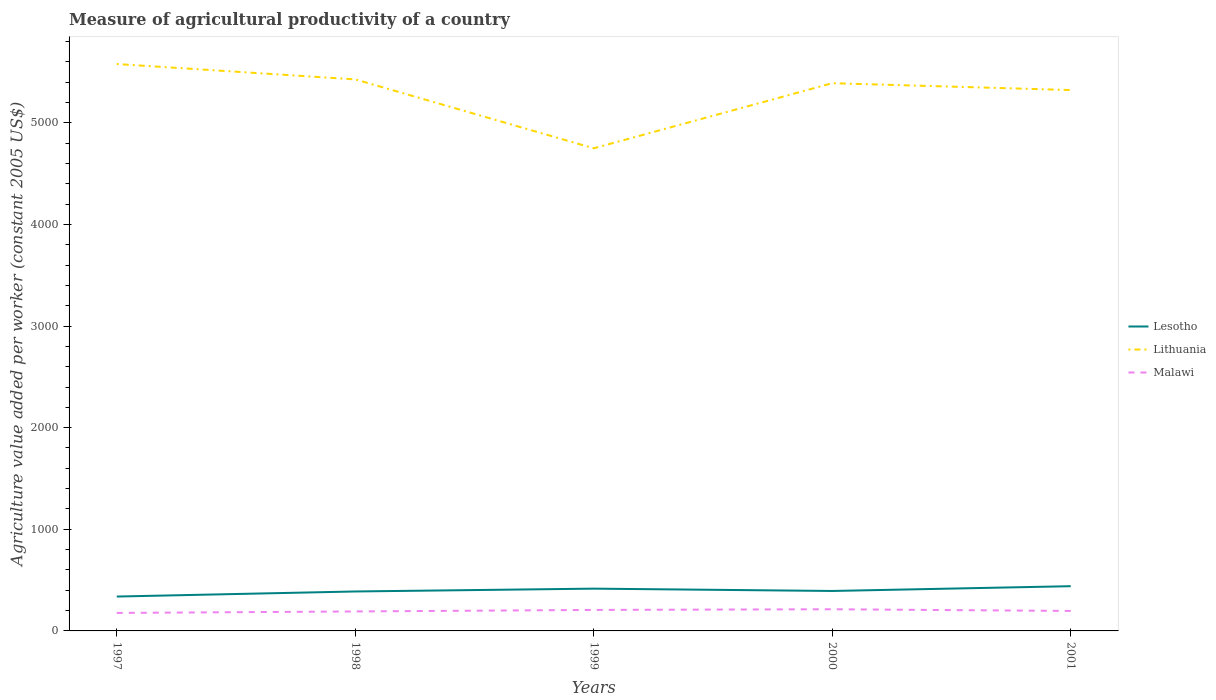Does the line corresponding to Lithuania intersect with the line corresponding to Lesotho?
Provide a succinct answer. No. Is the number of lines equal to the number of legend labels?
Make the answer very short. Yes. Across all years, what is the maximum measure of agricultural productivity in Malawi?
Offer a terse response. 177.04. In which year was the measure of agricultural productivity in Lithuania maximum?
Provide a short and direct response. 1999. What is the total measure of agricultural productivity in Lithuania in the graph?
Give a very brief answer. 256.21. What is the difference between the highest and the second highest measure of agricultural productivity in Lithuania?
Your response must be concise. 829.35. How many lines are there?
Provide a short and direct response. 3. How many years are there in the graph?
Keep it short and to the point. 5. What is the difference between two consecutive major ticks on the Y-axis?
Make the answer very short. 1000. Does the graph contain any zero values?
Your answer should be compact. No. Where does the legend appear in the graph?
Give a very brief answer. Center right. How are the legend labels stacked?
Give a very brief answer. Vertical. What is the title of the graph?
Offer a very short reply. Measure of agricultural productivity of a country. What is the label or title of the X-axis?
Make the answer very short. Years. What is the label or title of the Y-axis?
Offer a terse response. Agriculture value added per worker (constant 2005 US$). What is the Agriculture value added per worker (constant 2005 US$) of Lesotho in 1997?
Offer a terse response. 338.18. What is the Agriculture value added per worker (constant 2005 US$) in Lithuania in 1997?
Make the answer very short. 5578.12. What is the Agriculture value added per worker (constant 2005 US$) in Malawi in 1997?
Ensure brevity in your answer.  177.04. What is the Agriculture value added per worker (constant 2005 US$) of Lesotho in 1998?
Ensure brevity in your answer.  388.21. What is the Agriculture value added per worker (constant 2005 US$) of Lithuania in 1998?
Offer a terse response. 5426.79. What is the Agriculture value added per worker (constant 2005 US$) in Malawi in 1998?
Make the answer very short. 191.59. What is the Agriculture value added per worker (constant 2005 US$) in Lesotho in 1999?
Your answer should be compact. 416.03. What is the Agriculture value added per worker (constant 2005 US$) in Lithuania in 1999?
Keep it short and to the point. 4748.77. What is the Agriculture value added per worker (constant 2005 US$) in Malawi in 1999?
Your response must be concise. 206.56. What is the Agriculture value added per worker (constant 2005 US$) of Lesotho in 2000?
Provide a succinct answer. 393.16. What is the Agriculture value added per worker (constant 2005 US$) in Lithuania in 2000?
Offer a terse response. 5389.48. What is the Agriculture value added per worker (constant 2005 US$) of Malawi in 2000?
Give a very brief answer. 213.16. What is the Agriculture value added per worker (constant 2005 US$) in Lesotho in 2001?
Your answer should be very brief. 440.23. What is the Agriculture value added per worker (constant 2005 US$) of Lithuania in 2001?
Offer a terse response. 5321.91. What is the Agriculture value added per worker (constant 2005 US$) in Malawi in 2001?
Your answer should be compact. 196.64. Across all years, what is the maximum Agriculture value added per worker (constant 2005 US$) of Lesotho?
Your response must be concise. 440.23. Across all years, what is the maximum Agriculture value added per worker (constant 2005 US$) of Lithuania?
Your answer should be very brief. 5578.12. Across all years, what is the maximum Agriculture value added per worker (constant 2005 US$) in Malawi?
Offer a terse response. 213.16. Across all years, what is the minimum Agriculture value added per worker (constant 2005 US$) of Lesotho?
Keep it short and to the point. 338.18. Across all years, what is the minimum Agriculture value added per worker (constant 2005 US$) in Lithuania?
Your answer should be very brief. 4748.77. Across all years, what is the minimum Agriculture value added per worker (constant 2005 US$) in Malawi?
Make the answer very short. 177.04. What is the total Agriculture value added per worker (constant 2005 US$) in Lesotho in the graph?
Your answer should be very brief. 1975.81. What is the total Agriculture value added per worker (constant 2005 US$) in Lithuania in the graph?
Your answer should be compact. 2.65e+04. What is the total Agriculture value added per worker (constant 2005 US$) of Malawi in the graph?
Ensure brevity in your answer.  984.99. What is the difference between the Agriculture value added per worker (constant 2005 US$) in Lesotho in 1997 and that in 1998?
Offer a very short reply. -50.03. What is the difference between the Agriculture value added per worker (constant 2005 US$) in Lithuania in 1997 and that in 1998?
Keep it short and to the point. 151.33. What is the difference between the Agriculture value added per worker (constant 2005 US$) in Malawi in 1997 and that in 1998?
Your answer should be compact. -14.55. What is the difference between the Agriculture value added per worker (constant 2005 US$) in Lesotho in 1997 and that in 1999?
Your response must be concise. -77.84. What is the difference between the Agriculture value added per worker (constant 2005 US$) in Lithuania in 1997 and that in 1999?
Provide a short and direct response. 829.35. What is the difference between the Agriculture value added per worker (constant 2005 US$) of Malawi in 1997 and that in 1999?
Keep it short and to the point. -29.52. What is the difference between the Agriculture value added per worker (constant 2005 US$) in Lesotho in 1997 and that in 2000?
Provide a succinct answer. -54.98. What is the difference between the Agriculture value added per worker (constant 2005 US$) in Lithuania in 1997 and that in 2000?
Give a very brief answer. 188.64. What is the difference between the Agriculture value added per worker (constant 2005 US$) of Malawi in 1997 and that in 2000?
Offer a very short reply. -36.13. What is the difference between the Agriculture value added per worker (constant 2005 US$) in Lesotho in 1997 and that in 2001?
Your answer should be compact. -102.05. What is the difference between the Agriculture value added per worker (constant 2005 US$) in Lithuania in 1997 and that in 2001?
Make the answer very short. 256.21. What is the difference between the Agriculture value added per worker (constant 2005 US$) of Malawi in 1997 and that in 2001?
Your answer should be very brief. -19.6. What is the difference between the Agriculture value added per worker (constant 2005 US$) of Lesotho in 1998 and that in 1999?
Your answer should be compact. -27.81. What is the difference between the Agriculture value added per worker (constant 2005 US$) in Lithuania in 1998 and that in 1999?
Your answer should be compact. 678.02. What is the difference between the Agriculture value added per worker (constant 2005 US$) of Malawi in 1998 and that in 1999?
Give a very brief answer. -14.97. What is the difference between the Agriculture value added per worker (constant 2005 US$) in Lesotho in 1998 and that in 2000?
Provide a succinct answer. -4.95. What is the difference between the Agriculture value added per worker (constant 2005 US$) in Lithuania in 1998 and that in 2000?
Give a very brief answer. 37.32. What is the difference between the Agriculture value added per worker (constant 2005 US$) in Malawi in 1998 and that in 2000?
Give a very brief answer. -21.57. What is the difference between the Agriculture value added per worker (constant 2005 US$) in Lesotho in 1998 and that in 2001?
Make the answer very short. -52.02. What is the difference between the Agriculture value added per worker (constant 2005 US$) in Lithuania in 1998 and that in 2001?
Your answer should be very brief. 104.88. What is the difference between the Agriculture value added per worker (constant 2005 US$) of Malawi in 1998 and that in 2001?
Offer a very short reply. -5.05. What is the difference between the Agriculture value added per worker (constant 2005 US$) in Lesotho in 1999 and that in 2000?
Make the answer very short. 22.86. What is the difference between the Agriculture value added per worker (constant 2005 US$) in Lithuania in 1999 and that in 2000?
Offer a terse response. -640.71. What is the difference between the Agriculture value added per worker (constant 2005 US$) of Malawi in 1999 and that in 2000?
Provide a short and direct response. -6.6. What is the difference between the Agriculture value added per worker (constant 2005 US$) of Lesotho in 1999 and that in 2001?
Make the answer very short. -24.2. What is the difference between the Agriculture value added per worker (constant 2005 US$) in Lithuania in 1999 and that in 2001?
Offer a terse response. -573.14. What is the difference between the Agriculture value added per worker (constant 2005 US$) of Malawi in 1999 and that in 2001?
Provide a short and direct response. 9.92. What is the difference between the Agriculture value added per worker (constant 2005 US$) of Lesotho in 2000 and that in 2001?
Provide a short and direct response. -47.07. What is the difference between the Agriculture value added per worker (constant 2005 US$) in Lithuania in 2000 and that in 2001?
Your answer should be very brief. 67.57. What is the difference between the Agriculture value added per worker (constant 2005 US$) in Malawi in 2000 and that in 2001?
Your answer should be compact. 16.53. What is the difference between the Agriculture value added per worker (constant 2005 US$) in Lesotho in 1997 and the Agriculture value added per worker (constant 2005 US$) in Lithuania in 1998?
Your response must be concise. -5088.61. What is the difference between the Agriculture value added per worker (constant 2005 US$) in Lesotho in 1997 and the Agriculture value added per worker (constant 2005 US$) in Malawi in 1998?
Offer a terse response. 146.59. What is the difference between the Agriculture value added per worker (constant 2005 US$) in Lithuania in 1997 and the Agriculture value added per worker (constant 2005 US$) in Malawi in 1998?
Your answer should be compact. 5386.53. What is the difference between the Agriculture value added per worker (constant 2005 US$) in Lesotho in 1997 and the Agriculture value added per worker (constant 2005 US$) in Lithuania in 1999?
Make the answer very short. -4410.59. What is the difference between the Agriculture value added per worker (constant 2005 US$) of Lesotho in 1997 and the Agriculture value added per worker (constant 2005 US$) of Malawi in 1999?
Offer a terse response. 131.62. What is the difference between the Agriculture value added per worker (constant 2005 US$) in Lithuania in 1997 and the Agriculture value added per worker (constant 2005 US$) in Malawi in 1999?
Your response must be concise. 5371.56. What is the difference between the Agriculture value added per worker (constant 2005 US$) in Lesotho in 1997 and the Agriculture value added per worker (constant 2005 US$) in Lithuania in 2000?
Give a very brief answer. -5051.29. What is the difference between the Agriculture value added per worker (constant 2005 US$) of Lesotho in 1997 and the Agriculture value added per worker (constant 2005 US$) of Malawi in 2000?
Make the answer very short. 125.02. What is the difference between the Agriculture value added per worker (constant 2005 US$) in Lithuania in 1997 and the Agriculture value added per worker (constant 2005 US$) in Malawi in 2000?
Provide a short and direct response. 5364.95. What is the difference between the Agriculture value added per worker (constant 2005 US$) of Lesotho in 1997 and the Agriculture value added per worker (constant 2005 US$) of Lithuania in 2001?
Provide a short and direct response. -4983.73. What is the difference between the Agriculture value added per worker (constant 2005 US$) in Lesotho in 1997 and the Agriculture value added per worker (constant 2005 US$) in Malawi in 2001?
Your answer should be very brief. 141.54. What is the difference between the Agriculture value added per worker (constant 2005 US$) of Lithuania in 1997 and the Agriculture value added per worker (constant 2005 US$) of Malawi in 2001?
Provide a succinct answer. 5381.48. What is the difference between the Agriculture value added per worker (constant 2005 US$) of Lesotho in 1998 and the Agriculture value added per worker (constant 2005 US$) of Lithuania in 1999?
Your answer should be compact. -4360.55. What is the difference between the Agriculture value added per worker (constant 2005 US$) of Lesotho in 1998 and the Agriculture value added per worker (constant 2005 US$) of Malawi in 1999?
Give a very brief answer. 181.65. What is the difference between the Agriculture value added per worker (constant 2005 US$) of Lithuania in 1998 and the Agriculture value added per worker (constant 2005 US$) of Malawi in 1999?
Your answer should be compact. 5220.23. What is the difference between the Agriculture value added per worker (constant 2005 US$) of Lesotho in 1998 and the Agriculture value added per worker (constant 2005 US$) of Lithuania in 2000?
Offer a terse response. -5001.26. What is the difference between the Agriculture value added per worker (constant 2005 US$) in Lesotho in 1998 and the Agriculture value added per worker (constant 2005 US$) in Malawi in 2000?
Your response must be concise. 175.05. What is the difference between the Agriculture value added per worker (constant 2005 US$) in Lithuania in 1998 and the Agriculture value added per worker (constant 2005 US$) in Malawi in 2000?
Ensure brevity in your answer.  5213.63. What is the difference between the Agriculture value added per worker (constant 2005 US$) in Lesotho in 1998 and the Agriculture value added per worker (constant 2005 US$) in Lithuania in 2001?
Make the answer very short. -4933.69. What is the difference between the Agriculture value added per worker (constant 2005 US$) of Lesotho in 1998 and the Agriculture value added per worker (constant 2005 US$) of Malawi in 2001?
Give a very brief answer. 191.58. What is the difference between the Agriculture value added per worker (constant 2005 US$) of Lithuania in 1998 and the Agriculture value added per worker (constant 2005 US$) of Malawi in 2001?
Offer a terse response. 5230.16. What is the difference between the Agriculture value added per worker (constant 2005 US$) in Lesotho in 1999 and the Agriculture value added per worker (constant 2005 US$) in Lithuania in 2000?
Ensure brevity in your answer.  -4973.45. What is the difference between the Agriculture value added per worker (constant 2005 US$) in Lesotho in 1999 and the Agriculture value added per worker (constant 2005 US$) in Malawi in 2000?
Provide a succinct answer. 202.86. What is the difference between the Agriculture value added per worker (constant 2005 US$) in Lithuania in 1999 and the Agriculture value added per worker (constant 2005 US$) in Malawi in 2000?
Ensure brevity in your answer.  4535.6. What is the difference between the Agriculture value added per worker (constant 2005 US$) in Lesotho in 1999 and the Agriculture value added per worker (constant 2005 US$) in Lithuania in 2001?
Your response must be concise. -4905.88. What is the difference between the Agriculture value added per worker (constant 2005 US$) in Lesotho in 1999 and the Agriculture value added per worker (constant 2005 US$) in Malawi in 2001?
Provide a short and direct response. 219.39. What is the difference between the Agriculture value added per worker (constant 2005 US$) in Lithuania in 1999 and the Agriculture value added per worker (constant 2005 US$) in Malawi in 2001?
Keep it short and to the point. 4552.13. What is the difference between the Agriculture value added per worker (constant 2005 US$) in Lesotho in 2000 and the Agriculture value added per worker (constant 2005 US$) in Lithuania in 2001?
Make the answer very short. -4928.74. What is the difference between the Agriculture value added per worker (constant 2005 US$) in Lesotho in 2000 and the Agriculture value added per worker (constant 2005 US$) in Malawi in 2001?
Offer a very short reply. 196.53. What is the difference between the Agriculture value added per worker (constant 2005 US$) of Lithuania in 2000 and the Agriculture value added per worker (constant 2005 US$) of Malawi in 2001?
Ensure brevity in your answer.  5192.84. What is the average Agriculture value added per worker (constant 2005 US$) of Lesotho per year?
Your answer should be compact. 395.16. What is the average Agriculture value added per worker (constant 2005 US$) in Lithuania per year?
Ensure brevity in your answer.  5293.01. What is the average Agriculture value added per worker (constant 2005 US$) of Malawi per year?
Make the answer very short. 197. In the year 1997, what is the difference between the Agriculture value added per worker (constant 2005 US$) in Lesotho and Agriculture value added per worker (constant 2005 US$) in Lithuania?
Your answer should be compact. -5239.94. In the year 1997, what is the difference between the Agriculture value added per worker (constant 2005 US$) in Lesotho and Agriculture value added per worker (constant 2005 US$) in Malawi?
Provide a succinct answer. 161.15. In the year 1997, what is the difference between the Agriculture value added per worker (constant 2005 US$) in Lithuania and Agriculture value added per worker (constant 2005 US$) in Malawi?
Make the answer very short. 5401.08. In the year 1998, what is the difference between the Agriculture value added per worker (constant 2005 US$) in Lesotho and Agriculture value added per worker (constant 2005 US$) in Lithuania?
Provide a succinct answer. -5038.58. In the year 1998, what is the difference between the Agriculture value added per worker (constant 2005 US$) in Lesotho and Agriculture value added per worker (constant 2005 US$) in Malawi?
Your answer should be compact. 196.62. In the year 1998, what is the difference between the Agriculture value added per worker (constant 2005 US$) of Lithuania and Agriculture value added per worker (constant 2005 US$) of Malawi?
Offer a terse response. 5235.2. In the year 1999, what is the difference between the Agriculture value added per worker (constant 2005 US$) in Lesotho and Agriculture value added per worker (constant 2005 US$) in Lithuania?
Your response must be concise. -4332.74. In the year 1999, what is the difference between the Agriculture value added per worker (constant 2005 US$) in Lesotho and Agriculture value added per worker (constant 2005 US$) in Malawi?
Provide a short and direct response. 209.46. In the year 1999, what is the difference between the Agriculture value added per worker (constant 2005 US$) in Lithuania and Agriculture value added per worker (constant 2005 US$) in Malawi?
Your answer should be very brief. 4542.21. In the year 2000, what is the difference between the Agriculture value added per worker (constant 2005 US$) of Lesotho and Agriculture value added per worker (constant 2005 US$) of Lithuania?
Give a very brief answer. -4996.31. In the year 2000, what is the difference between the Agriculture value added per worker (constant 2005 US$) in Lesotho and Agriculture value added per worker (constant 2005 US$) in Malawi?
Your answer should be compact. 180. In the year 2000, what is the difference between the Agriculture value added per worker (constant 2005 US$) of Lithuania and Agriculture value added per worker (constant 2005 US$) of Malawi?
Your response must be concise. 5176.31. In the year 2001, what is the difference between the Agriculture value added per worker (constant 2005 US$) in Lesotho and Agriculture value added per worker (constant 2005 US$) in Lithuania?
Keep it short and to the point. -4881.68. In the year 2001, what is the difference between the Agriculture value added per worker (constant 2005 US$) in Lesotho and Agriculture value added per worker (constant 2005 US$) in Malawi?
Offer a very short reply. 243.59. In the year 2001, what is the difference between the Agriculture value added per worker (constant 2005 US$) of Lithuania and Agriculture value added per worker (constant 2005 US$) of Malawi?
Give a very brief answer. 5125.27. What is the ratio of the Agriculture value added per worker (constant 2005 US$) in Lesotho in 1997 to that in 1998?
Keep it short and to the point. 0.87. What is the ratio of the Agriculture value added per worker (constant 2005 US$) in Lithuania in 1997 to that in 1998?
Give a very brief answer. 1.03. What is the ratio of the Agriculture value added per worker (constant 2005 US$) of Malawi in 1997 to that in 1998?
Your response must be concise. 0.92. What is the ratio of the Agriculture value added per worker (constant 2005 US$) in Lesotho in 1997 to that in 1999?
Offer a terse response. 0.81. What is the ratio of the Agriculture value added per worker (constant 2005 US$) of Lithuania in 1997 to that in 1999?
Make the answer very short. 1.17. What is the ratio of the Agriculture value added per worker (constant 2005 US$) in Malawi in 1997 to that in 1999?
Your answer should be very brief. 0.86. What is the ratio of the Agriculture value added per worker (constant 2005 US$) in Lesotho in 1997 to that in 2000?
Your response must be concise. 0.86. What is the ratio of the Agriculture value added per worker (constant 2005 US$) in Lithuania in 1997 to that in 2000?
Your response must be concise. 1.03. What is the ratio of the Agriculture value added per worker (constant 2005 US$) in Malawi in 1997 to that in 2000?
Provide a succinct answer. 0.83. What is the ratio of the Agriculture value added per worker (constant 2005 US$) in Lesotho in 1997 to that in 2001?
Your response must be concise. 0.77. What is the ratio of the Agriculture value added per worker (constant 2005 US$) in Lithuania in 1997 to that in 2001?
Give a very brief answer. 1.05. What is the ratio of the Agriculture value added per worker (constant 2005 US$) in Malawi in 1997 to that in 2001?
Your answer should be very brief. 0.9. What is the ratio of the Agriculture value added per worker (constant 2005 US$) in Lesotho in 1998 to that in 1999?
Your response must be concise. 0.93. What is the ratio of the Agriculture value added per worker (constant 2005 US$) of Lithuania in 1998 to that in 1999?
Your response must be concise. 1.14. What is the ratio of the Agriculture value added per worker (constant 2005 US$) in Malawi in 1998 to that in 1999?
Keep it short and to the point. 0.93. What is the ratio of the Agriculture value added per worker (constant 2005 US$) in Lesotho in 1998 to that in 2000?
Keep it short and to the point. 0.99. What is the ratio of the Agriculture value added per worker (constant 2005 US$) in Malawi in 1998 to that in 2000?
Your response must be concise. 0.9. What is the ratio of the Agriculture value added per worker (constant 2005 US$) of Lesotho in 1998 to that in 2001?
Give a very brief answer. 0.88. What is the ratio of the Agriculture value added per worker (constant 2005 US$) of Lithuania in 1998 to that in 2001?
Give a very brief answer. 1.02. What is the ratio of the Agriculture value added per worker (constant 2005 US$) of Malawi in 1998 to that in 2001?
Offer a terse response. 0.97. What is the ratio of the Agriculture value added per worker (constant 2005 US$) of Lesotho in 1999 to that in 2000?
Your answer should be very brief. 1.06. What is the ratio of the Agriculture value added per worker (constant 2005 US$) in Lithuania in 1999 to that in 2000?
Provide a short and direct response. 0.88. What is the ratio of the Agriculture value added per worker (constant 2005 US$) in Malawi in 1999 to that in 2000?
Keep it short and to the point. 0.97. What is the ratio of the Agriculture value added per worker (constant 2005 US$) in Lesotho in 1999 to that in 2001?
Keep it short and to the point. 0.94. What is the ratio of the Agriculture value added per worker (constant 2005 US$) in Lithuania in 1999 to that in 2001?
Keep it short and to the point. 0.89. What is the ratio of the Agriculture value added per worker (constant 2005 US$) of Malawi in 1999 to that in 2001?
Offer a terse response. 1.05. What is the ratio of the Agriculture value added per worker (constant 2005 US$) in Lesotho in 2000 to that in 2001?
Give a very brief answer. 0.89. What is the ratio of the Agriculture value added per worker (constant 2005 US$) of Lithuania in 2000 to that in 2001?
Offer a very short reply. 1.01. What is the ratio of the Agriculture value added per worker (constant 2005 US$) of Malawi in 2000 to that in 2001?
Give a very brief answer. 1.08. What is the difference between the highest and the second highest Agriculture value added per worker (constant 2005 US$) in Lesotho?
Your response must be concise. 24.2. What is the difference between the highest and the second highest Agriculture value added per worker (constant 2005 US$) of Lithuania?
Ensure brevity in your answer.  151.33. What is the difference between the highest and the second highest Agriculture value added per worker (constant 2005 US$) in Malawi?
Give a very brief answer. 6.6. What is the difference between the highest and the lowest Agriculture value added per worker (constant 2005 US$) of Lesotho?
Provide a succinct answer. 102.05. What is the difference between the highest and the lowest Agriculture value added per worker (constant 2005 US$) in Lithuania?
Ensure brevity in your answer.  829.35. What is the difference between the highest and the lowest Agriculture value added per worker (constant 2005 US$) of Malawi?
Your answer should be very brief. 36.13. 